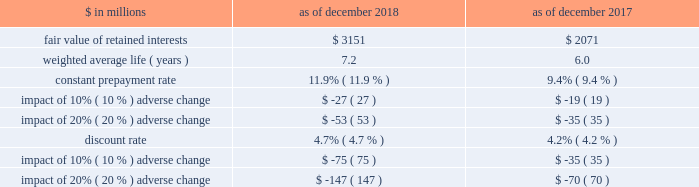The goldman sachs group , inc .
And subsidiaries notes to consolidated financial statements 2030 purchased interests represent senior and subordinated interests , purchased in connection with secondary market-making activities , in securitization entities in which the firm also holds retained interests .
2030 substantially all of the total outstanding principal amount and total retained interests relate to securitizations during 2014 and thereafter as of december 2018 , and relate to securitizations during 2012 and thereafter as of december 2017 .
2030 the fair value of retained interests was $ 3.28 billion as of december 2018 and $ 2.13 billion as of december 2017 .
In addition to the interests in the table above , the firm had other continuing involvement in the form of derivative transactions and commitments with certain nonconsolidated vies .
The carrying value of these derivatives and commitments was a net asset of $ 75 million as of december 2018 and $ 86 million as of december 2017 , and the notional amount of these derivatives and commitments was $ 1.09 billion as of december 2018 and $ 1.26 billion as of december 2017 .
The notional amounts of these derivatives and commitments are included in maximum exposure to loss in the nonconsolidated vie table in note 12 .
The table below presents information about the weighted average key economic assumptions used in measuring the fair value of mortgage-backed retained interests. .
In the table above : 2030 amounts do not reflect the benefit of other financial instruments that are held to mitigate risks inherent in these retained interests .
2030 changes in fair value based on an adverse variation in assumptions generally cannot be extrapolated because the relationship of the change in assumptions to the change in fair value is not usually linear .
2030 the impact of a change in a particular assumption is calculated independently of changes in any other assumption .
In practice , simultaneous changes in assumptions might magnify or counteract the sensitivities disclosed above .
2030 the constant prepayment rate is included only for positions for which it is a key assumption in the determination of fair value .
2030 the discount rate for retained interests that relate to u.s .
Government agency-issued collateralized mortgage obligations does not include any credit loss .
Expected credit loss assumptions are reflected in the discount rate for the remainder of retained interests .
The firm has other retained interests not reflected in the table above with a fair value of $ 133 million and a weighted average life of 4.2 years as of december 2018 , and a fair value of $ 56 million and a weighted average life of 4.5 years as of december 2017 .
Due to the nature and fair value of certain of these retained interests , the weighted average assumptions for constant prepayment and discount rates and the related sensitivity to adverse changes are not meaningful as of both december 2018 and december 2017 .
The firm 2019s maximum exposure to adverse changes in the value of these interests is the carrying value of $ 133 million as of december 2018 and $ 56 million as of december 2017 .
Note 12 .
Variable interest entities a variable interest in a vie is an investment ( e.g. , debt or equity ) or other interest ( e.g. , derivatives or loans and lending commitments ) that will absorb portions of the vie 2019s expected losses and/or receive portions of the vie 2019s expected residual returns .
The firm 2019s variable interests in vies include senior and subordinated debt ; loans and lending commitments ; limited and general partnership interests ; preferred and common equity ; derivatives that may include foreign currency , equity and/or credit risk ; guarantees ; and certain of the fees the firm receives from investment funds .
Certain interest rate , foreign currency and credit derivatives the firm enters into with vies are not variable interests because they create , rather than absorb , risk .
Vies generally finance the purchase of assets by issuing debt and equity securities that are either collateralized by or indexed to the assets held by the vie .
The debt and equity securities issued by a vie may include tranches of varying levels of subordination .
The firm 2019s involvement with vies includes securitization of financial assets , as described in note 11 , and investments in and loans to other types of vies , as described below .
See note 11 for further information about securitization activities , including the definition of beneficial interests .
See note 3 for the firm 2019s consolidation policies , including the definition of a vie .
Goldman sachs 2018 form 10-k 149 .
What was the change in the weighted average life ( years ) as of december 2018 and december 2017?\\n? 
Computations: (7.2 - 6)
Answer: 1.2. 